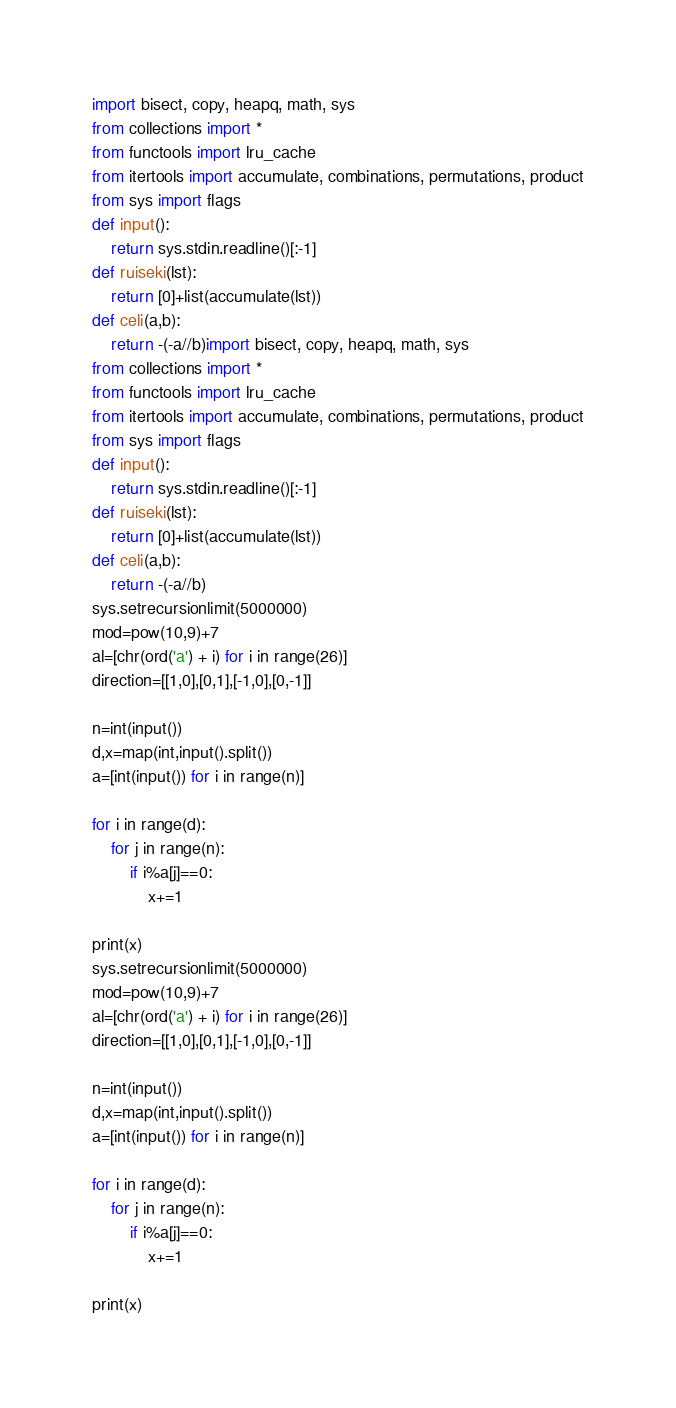<code> <loc_0><loc_0><loc_500><loc_500><_Python_>import bisect, copy, heapq, math, sys
from collections import *
from functools import lru_cache
from itertools import accumulate, combinations, permutations, product
from sys import flags
def input():
    return sys.stdin.readline()[:-1]
def ruiseki(lst):
    return [0]+list(accumulate(lst))
def celi(a,b):
    return -(-a//b)import bisect, copy, heapq, math, sys
from collections import *
from functools import lru_cache
from itertools import accumulate, combinations, permutations, product
from sys import flags
def input():
    return sys.stdin.readline()[:-1]
def ruiseki(lst):
    return [0]+list(accumulate(lst))
def celi(a,b):
    return -(-a//b)
sys.setrecursionlimit(5000000)
mod=pow(10,9)+7
al=[chr(ord('a') + i) for i in range(26)]
direction=[[1,0],[0,1],[-1,0],[0,-1]]

n=int(input())
d,x=map(int,input().split())
a=[int(input()) for i in range(n)]

for i in range(d):
    for j in range(n):
        if i%a[j]==0:
            x+=1

print(x)
sys.setrecursionlimit(5000000)
mod=pow(10,9)+7
al=[chr(ord('a') + i) for i in range(26)]
direction=[[1,0],[0,1],[-1,0],[0,-1]]

n=int(input())
d,x=map(int,input().split())
a=[int(input()) for i in range(n)]

for i in range(d):
    for j in range(n):
        if i%a[j]==0:
            x+=1

print(x)</code> 